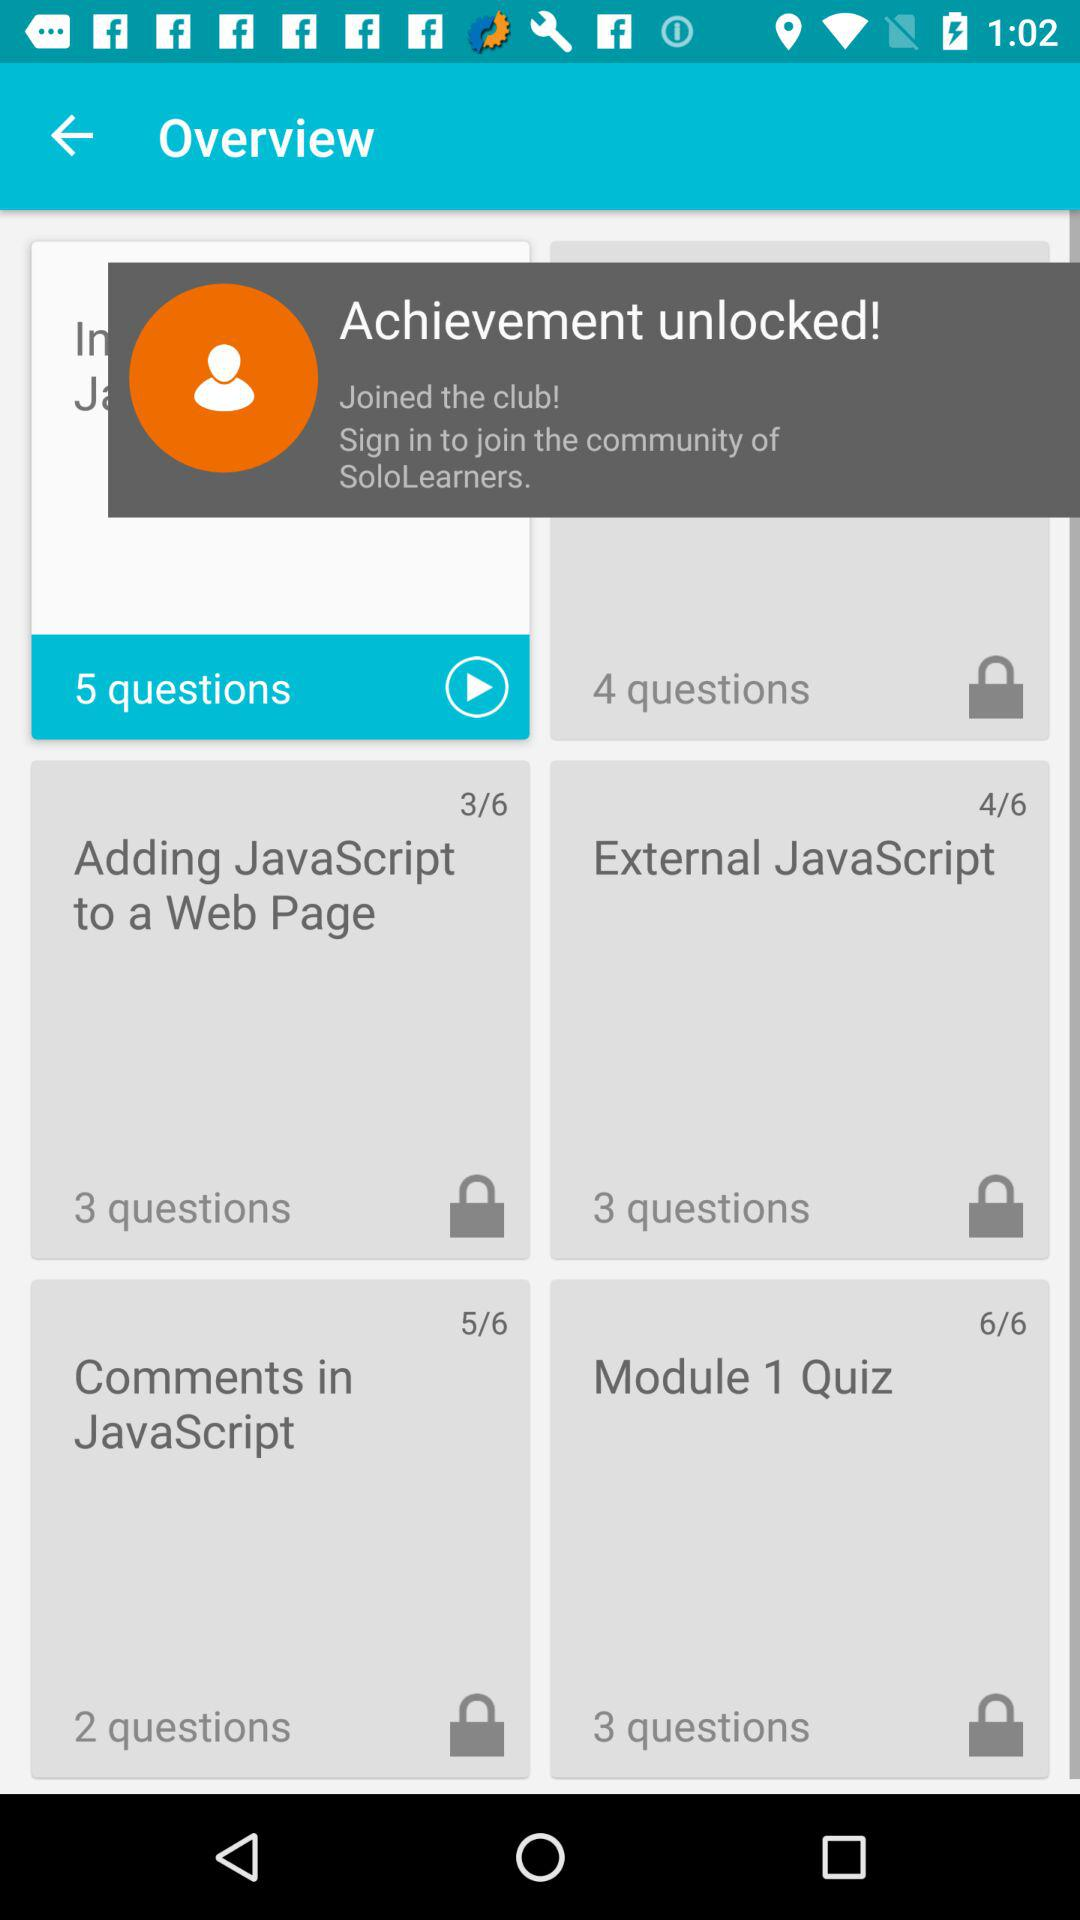What is the total count of "Module 1 Quiz"? The total count of the module 1 quiz is 6. 